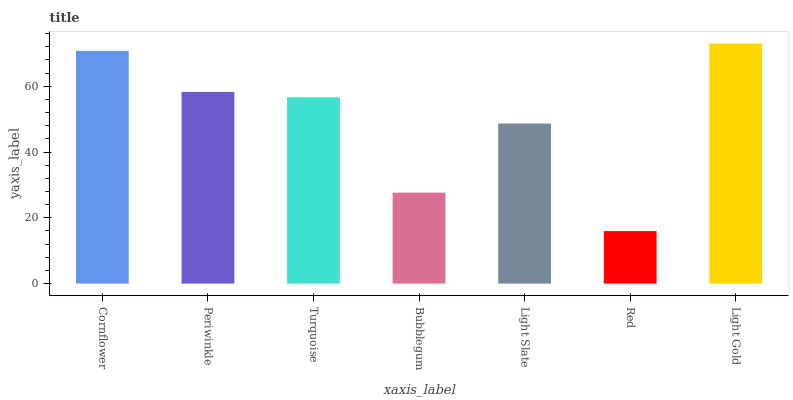Is Red the minimum?
Answer yes or no. Yes. Is Light Gold the maximum?
Answer yes or no. Yes. Is Periwinkle the minimum?
Answer yes or no. No. Is Periwinkle the maximum?
Answer yes or no. No. Is Cornflower greater than Periwinkle?
Answer yes or no. Yes. Is Periwinkle less than Cornflower?
Answer yes or no. Yes. Is Periwinkle greater than Cornflower?
Answer yes or no. No. Is Cornflower less than Periwinkle?
Answer yes or no. No. Is Turquoise the high median?
Answer yes or no. Yes. Is Turquoise the low median?
Answer yes or no. Yes. Is Bubblegum the high median?
Answer yes or no. No. Is Light Gold the low median?
Answer yes or no. No. 